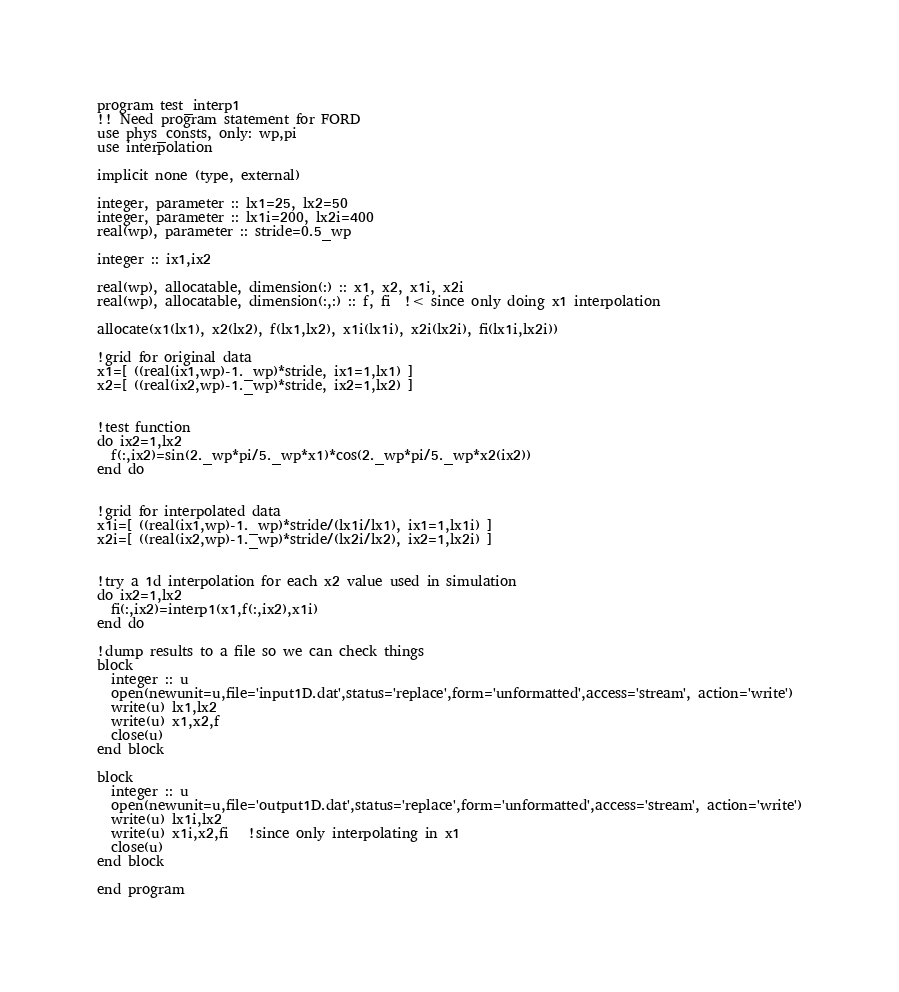Convert code to text. <code><loc_0><loc_0><loc_500><loc_500><_FORTRAN_>program test_interp1
!! Need program statement for FORD
use phys_consts, only: wp,pi
use interpolation

implicit none (type, external)

integer, parameter :: lx1=25, lx2=50
integer, parameter :: lx1i=200, lx2i=400
real(wp), parameter :: stride=0.5_wp

integer :: ix1,ix2

real(wp), allocatable, dimension(:) :: x1, x2, x1i, x2i
real(wp), allocatable, dimension(:,:) :: f, fi  !< since only doing x1 interpolation

allocate(x1(lx1), x2(lx2), f(lx1,lx2), x1i(lx1i), x2i(lx2i), fi(lx1i,lx2i))

!grid for original data
x1=[ ((real(ix1,wp)-1._wp)*stride, ix1=1,lx1) ]
x2=[ ((real(ix2,wp)-1._wp)*stride, ix2=1,lx2) ]


!test function
do ix2=1,lx2
  f(:,ix2)=sin(2._wp*pi/5._wp*x1)*cos(2._wp*pi/5._wp*x2(ix2))
end do


!grid for interpolated data
x1i=[ ((real(ix1,wp)-1._wp)*stride/(lx1i/lx1), ix1=1,lx1i) ]
x2i=[ ((real(ix2,wp)-1._wp)*stride/(lx2i/lx2), ix2=1,lx2i) ]


!try a 1d interpolation for each x2 value used in simulation
do ix2=1,lx2
  fi(:,ix2)=interp1(x1,f(:,ix2),x1i)
end do

!dump results to a file so we can check things
block
  integer :: u
  open(newunit=u,file='input1D.dat',status='replace',form='unformatted',access='stream', action='write')
  write(u) lx1,lx2
  write(u) x1,x2,f
  close(u)
end block

block
  integer :: u
  open(newunit=u,file='output1D.dat',status='replace',form='unformatted',access='stream', action='write')
  write(u) lx1i,lx2
  write(u) x1i,x2,fi   !since only interpolating in x1
  close(u)
end block

end program
</code> 